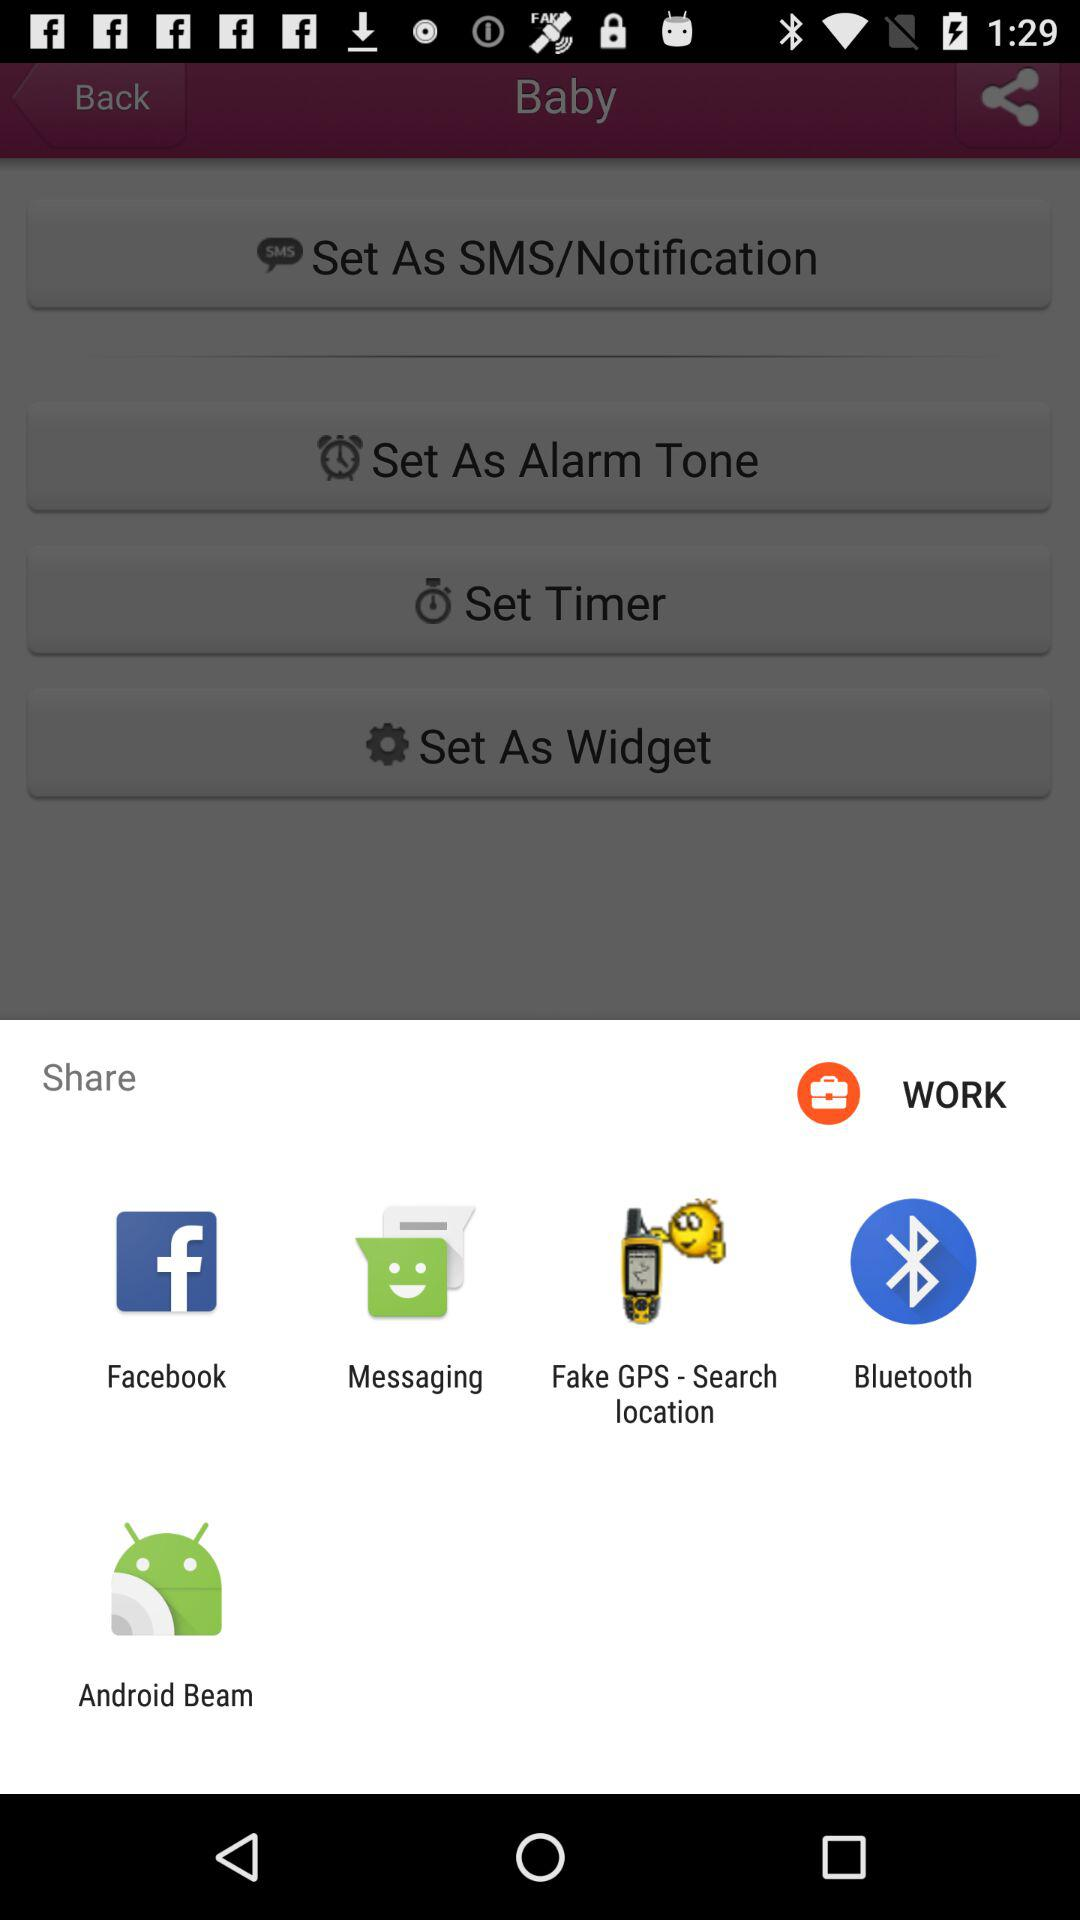Which app can we use to share? You can use "Facebook", "Messaging", "Fake GPS - Search location", "Bluetooth" and "Android Beam" to share. 